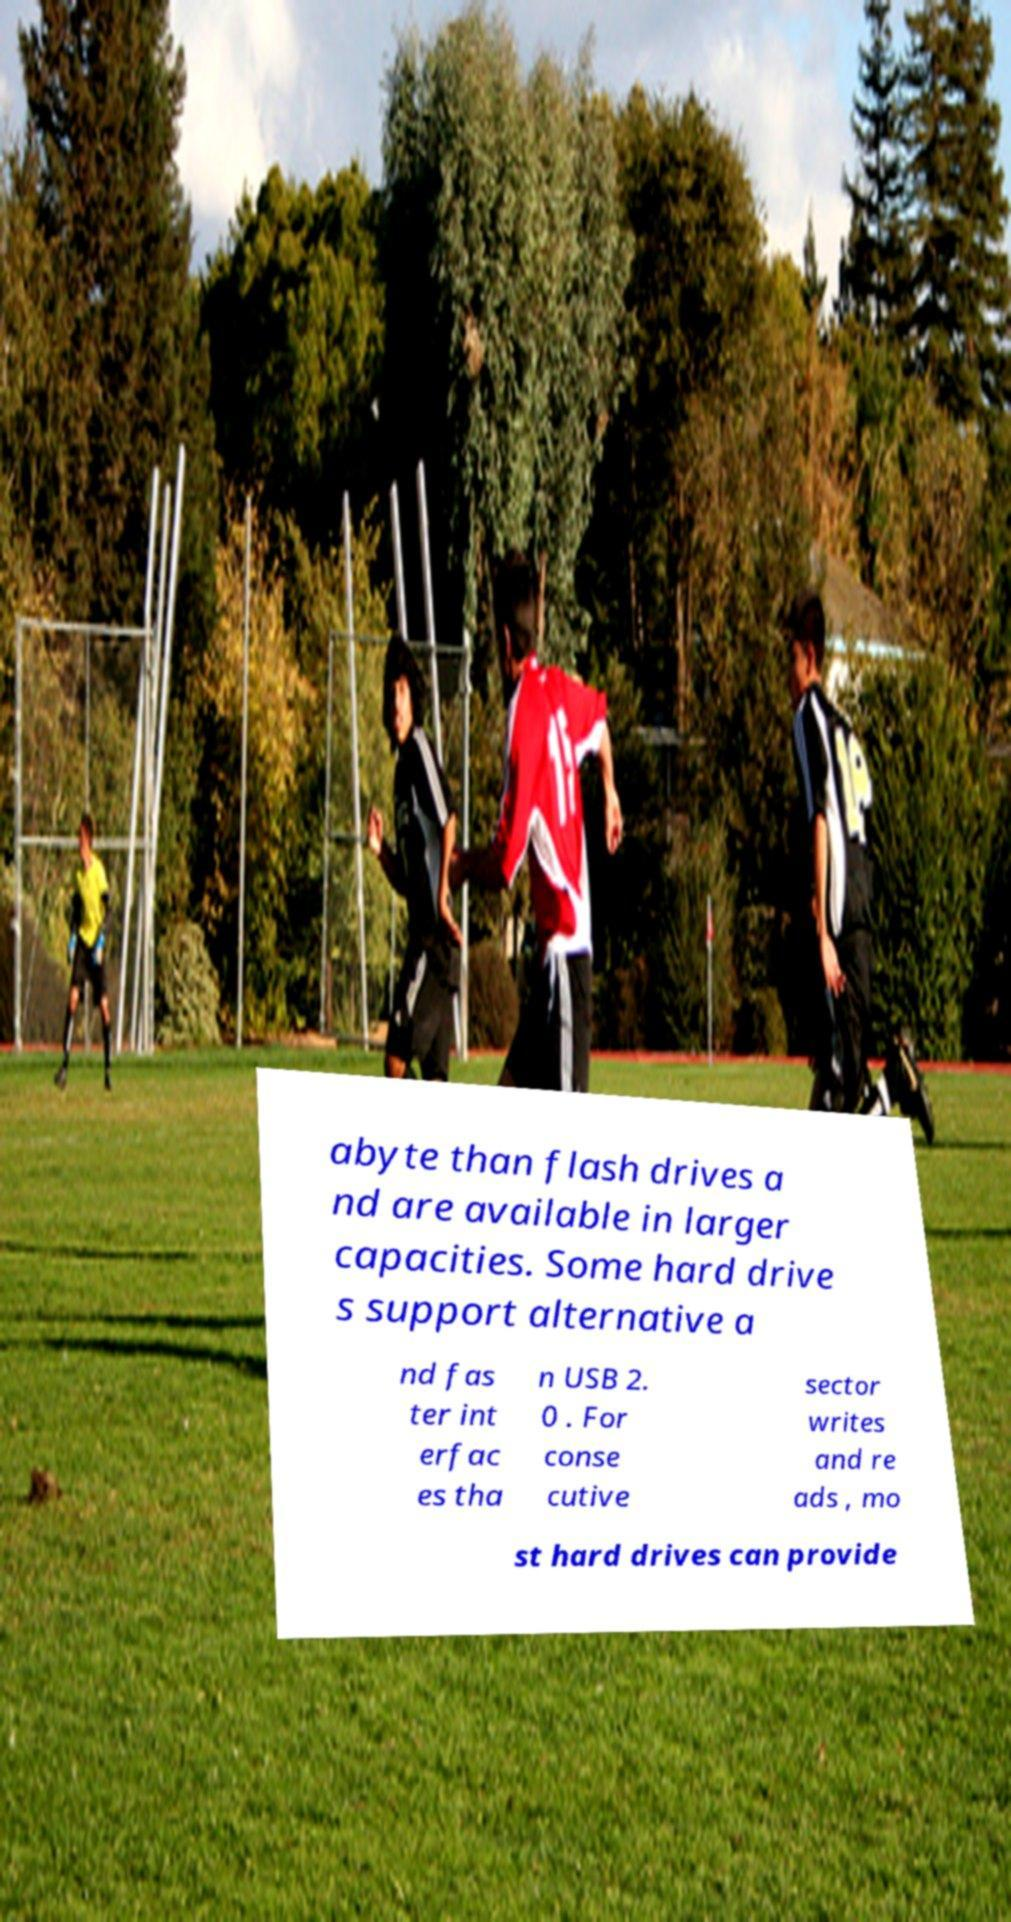Please identify and transcribe the text found in this image. abyte than flash drives a nd are available in larger capacities. Some hard drive s support alternative a nd fas ter int erfac es tha n USB 2. 0 . For conse cutive sector writes and re ads , mo st hard drives can provide 